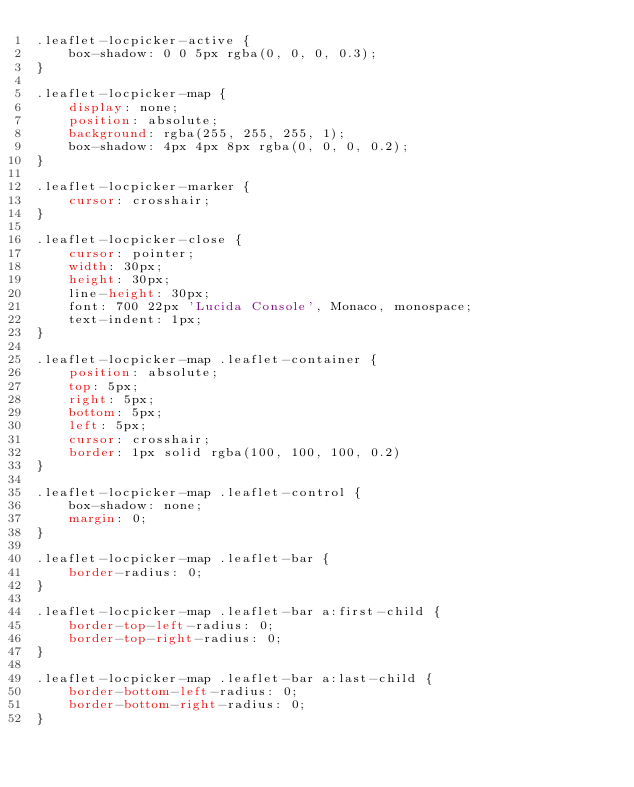Convert code to text. <code><loc_0><loc_0><loc_500><loc_500><_CSS_>.leaflet-locpicker-active {
    box-shadow: 0 0 5px rgba(0, 0, 0, 0.3);
}

.leaflet-locpicker-map {
    display: none;
    position: absolute;
    background: rgba(255, 255, 255, 1);
    box-shadow: 4px 4px 8px rgba(0, 0, 0, 0.2);
}

.leaflet-locpicker-marker {
    cursor: crosshair;
}

.leaflet-locpicker-close {
    cursor: pointer;
    width: 30px;
    height: 30px;
    line-height: 30px;
    font: 700 22px 'Lucida Console', Monaco, monospace;
    text-indent: 1px;
}

.leaflet-locpicker-map .leaflet-container {
    position: absolute;
    top: 5px;
    right: 5px;
    bottom: 5px;
    left: 5px;
    cursor: crosshair;
    border: 1px solid rgba(100, 100, 100, 0.2)
}

.leaflet-locpicker-map .leaflet-control {
    box-shadow: none;
    margin: 0;
}

.leaflet-locpicker-map .leaflet-bar {
    border-radius: 0;
}

.leaflet-locpicker-map .leaflet-bar a:first-child {
    border-top-left-radius: 0;
    border-top-right-radius: 0;
}

.leaflet-locpicker-map .leaflet-bar a:last-child {
    border-bottom-left-radius: 0;
    border-bottom-right-radius: 0;
}

</code> 